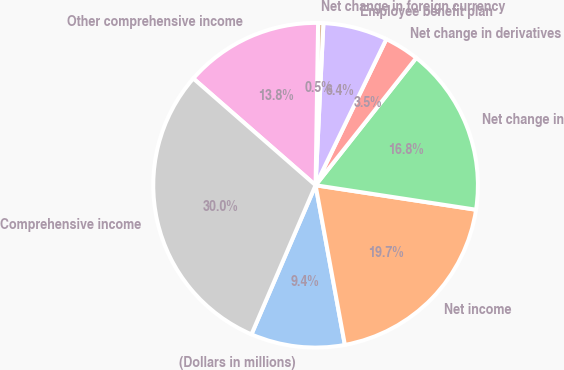Convert chart to OTSL. <chart><loc_0><loc_0><loc_500><loc_500><pie_chart><fcel>(Dollars in millions)<fcel>Net income<fcel>Net change in<fcel>Net change in derivatives<fcel>Employee benefit plan<fcel>Net change in foreign currency<fcel>Other comprehensive income<fcel>Comprehensive income<nl><fcel>9.35%<fcel>19.7%<fcel>16.76%<fcel>3.47%<fcel>6.41%<fcel>0.52%<fcel>13.82%<fcel>29.96%<nl></chart> 